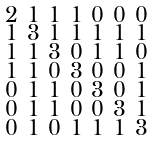Convert formula to latex. <formula><loc_0><loc_0><loc_500><loc_500>\begin{smallmatrix} 2 & 1 & 1 & 1 & 0 & 0 & 0 \\ 1 & 3 & 1 & 1 & 1 & 1 & 1 \\ 1 & 1 & 3 & 0 & 1 & 1 & 0 \\ 1 & 1 & 0 & 3 & 0 & 0 & 1 \\ 0 & 1 & 1 & 0 & 3 & 0 & 1 \\ 0 & 1 & 1 & 0 & 0 & 3 & 1 \\ 0 & 1 & 0 & 1 & 1 & 1 & 3 \end{smallmatrix}</formula> 